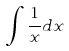<formula> <loc_0><loc_0><loc_500><loc_500>\int \frac { 1 } { x } d x</formula> 